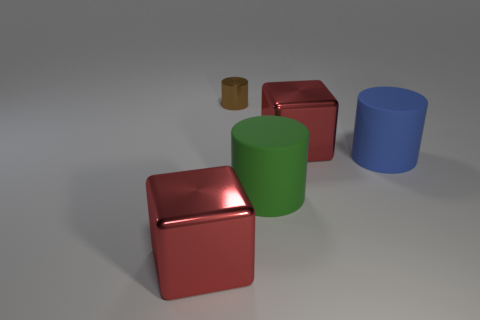There is a big metallic cube on the left side of the large green object; is its color the same as the metal object on the right side of the big green rubber cylinder?
Provide a succinct answer. Yes. Is the material of the brown thing the same as the blue cylinder?
Provide a short and direct response. No. Is there a red block that has the same material as the brown cylinder?
Your response must be concise. Yes. Are there more cylinders in front of the brown metallic object than red shiny blocks that are behind the blue matte object?
Your response must be concise. Yes. The green rubber cylinder has what size?
Ensure brevity in your answer.  Large. There is a large red metallic object that is in front of the blue rubber thing; what shape is it?
Your answer should be compact. Cube. Are there an equal number of red blocks to the left of the blue matte object and large red things?
Ensure brevity in your answer.  Yes. The blue rubber object has what shape?
Make the answer very short. Cylinder. Is there anything else that is the same color as the small metal cylinder?
Your response must be concise. No. There is a block in front of the blue rubber thing; does it have the same size as the red metallic block on the right side of the brown metallic object?
Offer a terse response. Yes. 